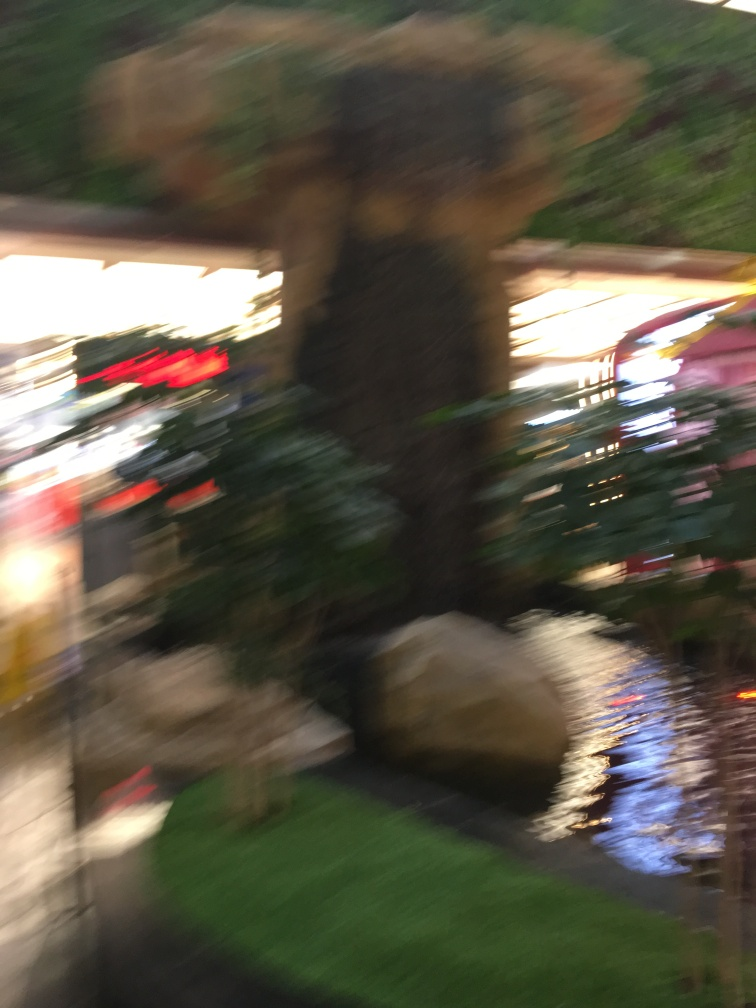How might the blurriness of this image affect its potential uses? The blurriness limits the image's usability for purposes that require clear, detailed visuals, such as a reference photo for detailed work. However, it could be used artistically to convey motion, energy, or a dreamlike quality in projects that benefit from such abstract visuals. 